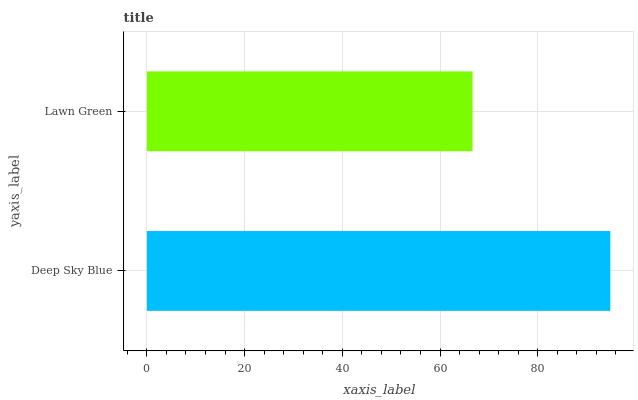Is Lawn Green the minimum?
Answer yes or no. Yes. Is Deep Sky Blue the maximum?
Answer yes or no. Yes. Is Lawn Green the maximum?
Answer yes or no. No. Is Deep Sky Blue greater than Lawn Green?
Answer yes or no. Yes. Is Lawn Green less than Deep Sky Blue?
Answer yes or no. Yes. Is Lawn Green greater than Deep Sky Blue?
Answer yes or no. No. Is Deep Sky Blue less than Lawn Green?
Answer yes or no. No. Is Deep Sky Blue the high median?
Answer yes or no. Yes. Is Lawn Green the low median?
Answer yes or no. Yes. Is Lawn Green the high median?
Answer yes or no. No. Is Deep Sky Blue the low median?
Answer yes or no. No. 